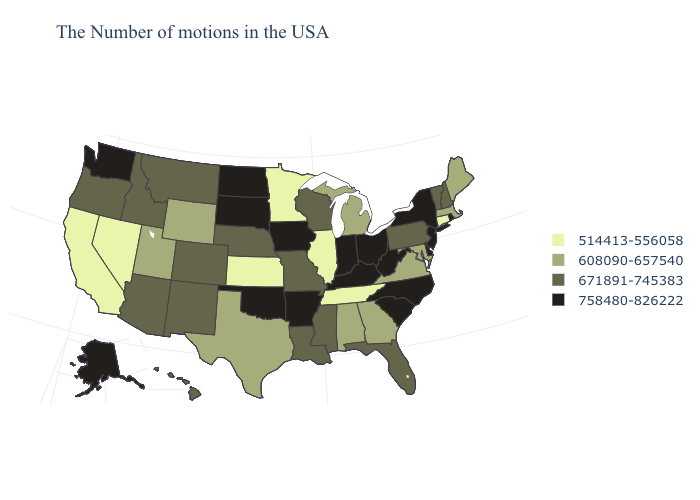Among the states that border Alabama , does Florida have the highest value?
Give a very brief answer. Yes. Is the legend a continuous bar?
Quick response, please. No. Among the states that border Montana , does South Dakota have the lowest value?
Short answer required. No. Which states have the lowest value in the USA?
Write a very short answer. Connecticut, Tennessee, Illinois, Minnesota, Kansas, Nevada, California. What is the highest value in states that border Colorado?
Write a very short answer. 758480-826222. Name the states that have a value in the range 514413-556058?
Quick response, please. Connecticut, Tennessee, Illinois, Minnesota, Kansas, Nevada, California. What is the value of Wyoming?
Write a very short answer. 608090-657540. Name the states that have a value in the range 758480-826222?
Write a very short answer. Rhode Island, New York, New Jersey, Delaware, North Carolina, South Carolina, West Virginia, Ohio, Kentucky, Indiana, Arkansas, Iowa, Oklahoma, South Dakota, North Dakota, Washington, Alaska. Which states have the lowest value in the USA?
Keep it brief. Connecticut, Tennessee, Illinois, Minnesota, Kansas, Nevada, California. What is the lowest value in the Northeast?
Be succinct. 514413-556058. What is the lowest value in the South?
Short answer required. 514413-556058. Name the states that have a value in the range 758480-826222?
Quick response, please. Rhode Island, New York, New Jersey, Delaware, North Carolina, South Carolina, West Virginia, Ohio, Kentucky, Indiana, Arkansas, Iowa, Oklahoma, South Dakota, North Dakota, Washington, Alaska. What is the value of Indiana?
Answer briefly. 758480-826222. Among the states that border California , does Oregon have the lowest value?
Concise answer only. No. What is the value of Tennessee?
Keep it brief. 514413-556058. 